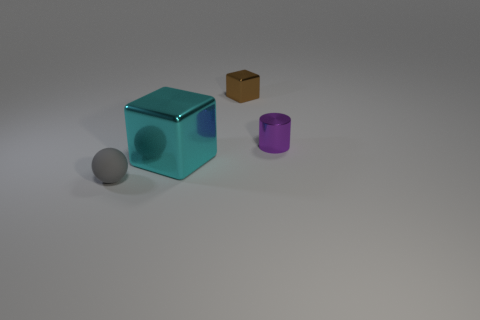Are there any metal things right of the big cyan block?
Keep it short and to the point. Yes. What is the color of the metal thing in front of the small metallic thing in front of the cube on the right side of the cyan shiny cube?
Ensure brevity in your answer.  Cyan. What shape is the purple shiny object that is the same size as the brown metallic block?
Offer a very short reply. Cylinder. Are there more large gray metallic objects than tiny matte things?
Provide a short and direct response. No. There is a shiny object that is in front of the small purple cylinder; is there a large cyan block to the left of it?
Ensure brevity in your answer.  No. There is another small thing that is the same shape as the cyan object; what is its color?
Your answer should be compact. Brown. Is there any other thing that has the same shape as the small rubber thing?
Make the answer very short. No. The cube that is made of the same material as the big thing is what color?
Offer a terse response. Brown. Is there a big cyan metallic cube that is in front of the tiny thing that is to the left of the block that is in front of the brown block?
Offer a terse response. No. Are there fewer tiny cylinders that are behind the tiny brown metal block than purple shiny cylinders that are right of the cyan metal object?
Provide a succinct answer. Yes. 